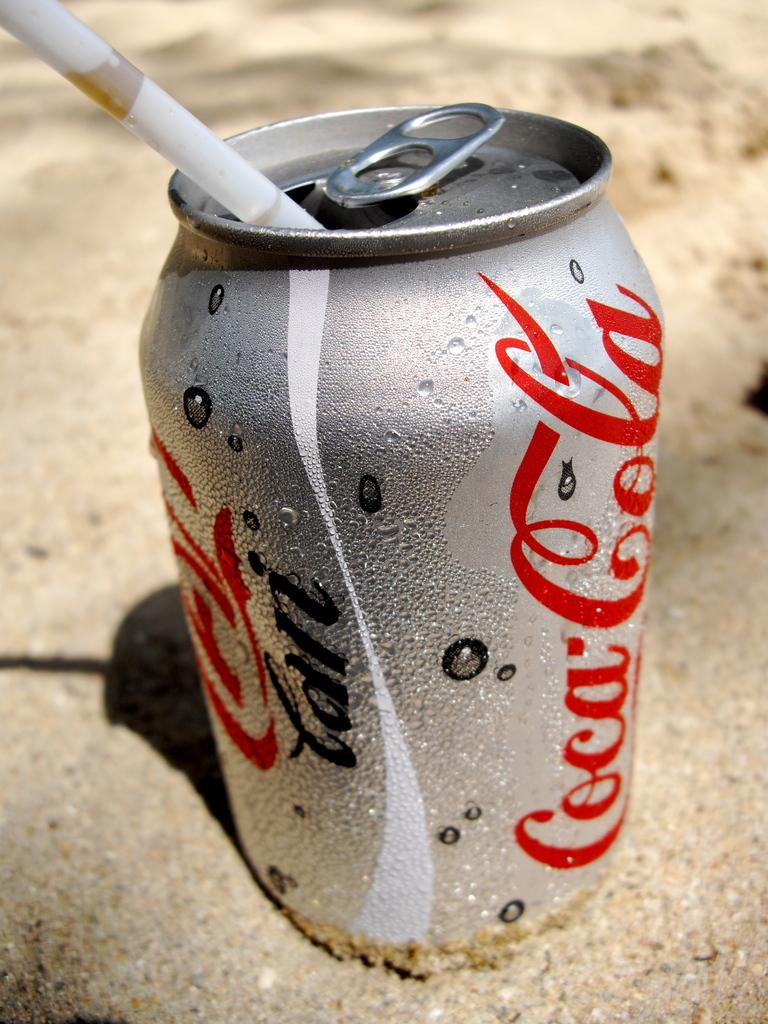<image>
Give a short and clear explanation of the subsequent image. A can of coca cola sits on the beach in the sand 